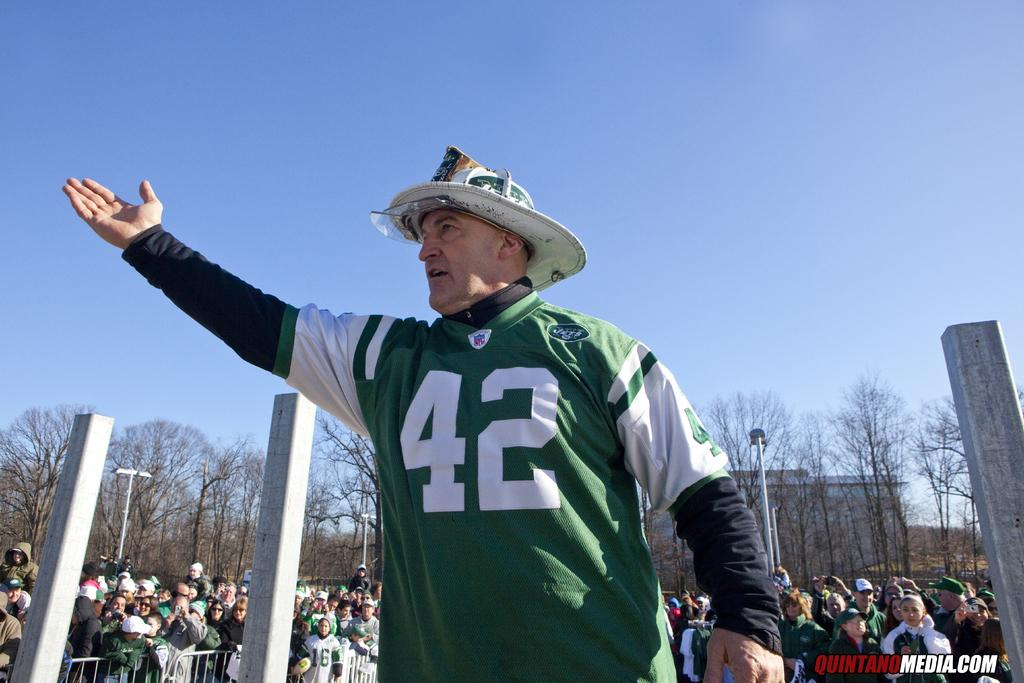<image>
Summarize the visual content of the image. A middle-aged man in a firefighter's hat and a Jets NFL jersey is reaching to the sky outside on a clear day. 